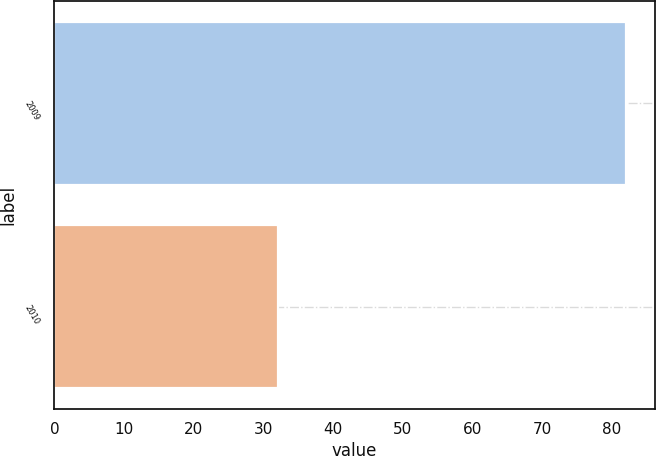Convert chart. <chart><loc_0><loc_0><loc_500><loc_500><bar_chart><fcel>2009<fcel>2010<nl><fcel>82<fcel>32<nl></chart> 